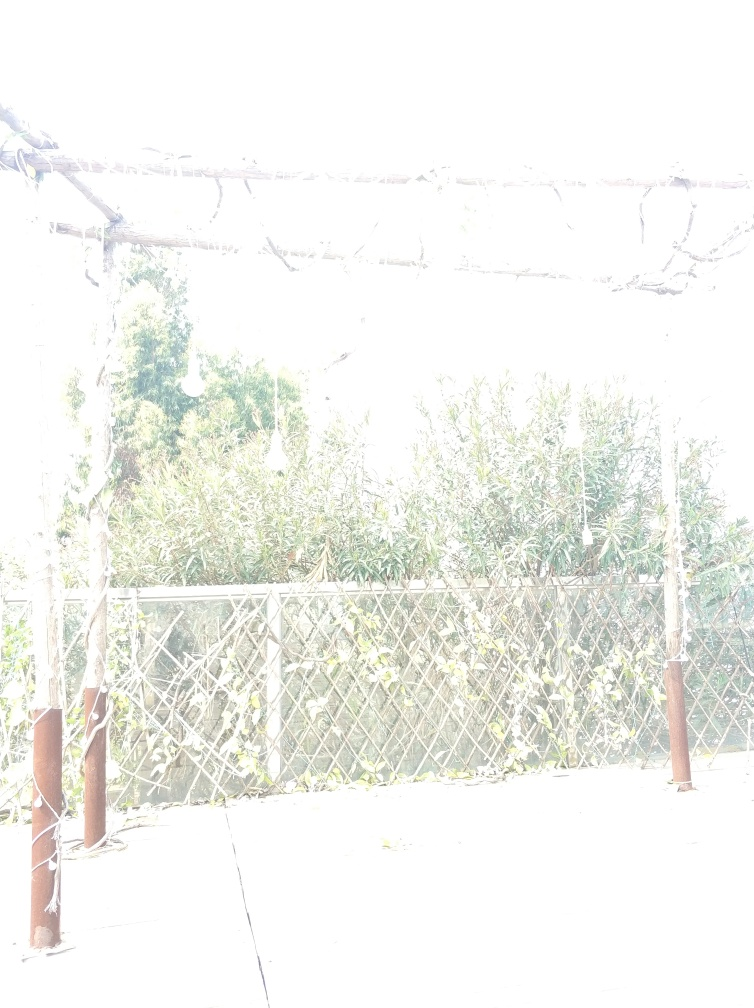Can you tell what time of day this photo was taken? Due to the overexposure, it's challenging to determine the exact time of day based solely on the lighting in the image. However, the natural light suggests it could be during daylight hours, most likely when the sun is bright, exacerbating the overexposure issue. 